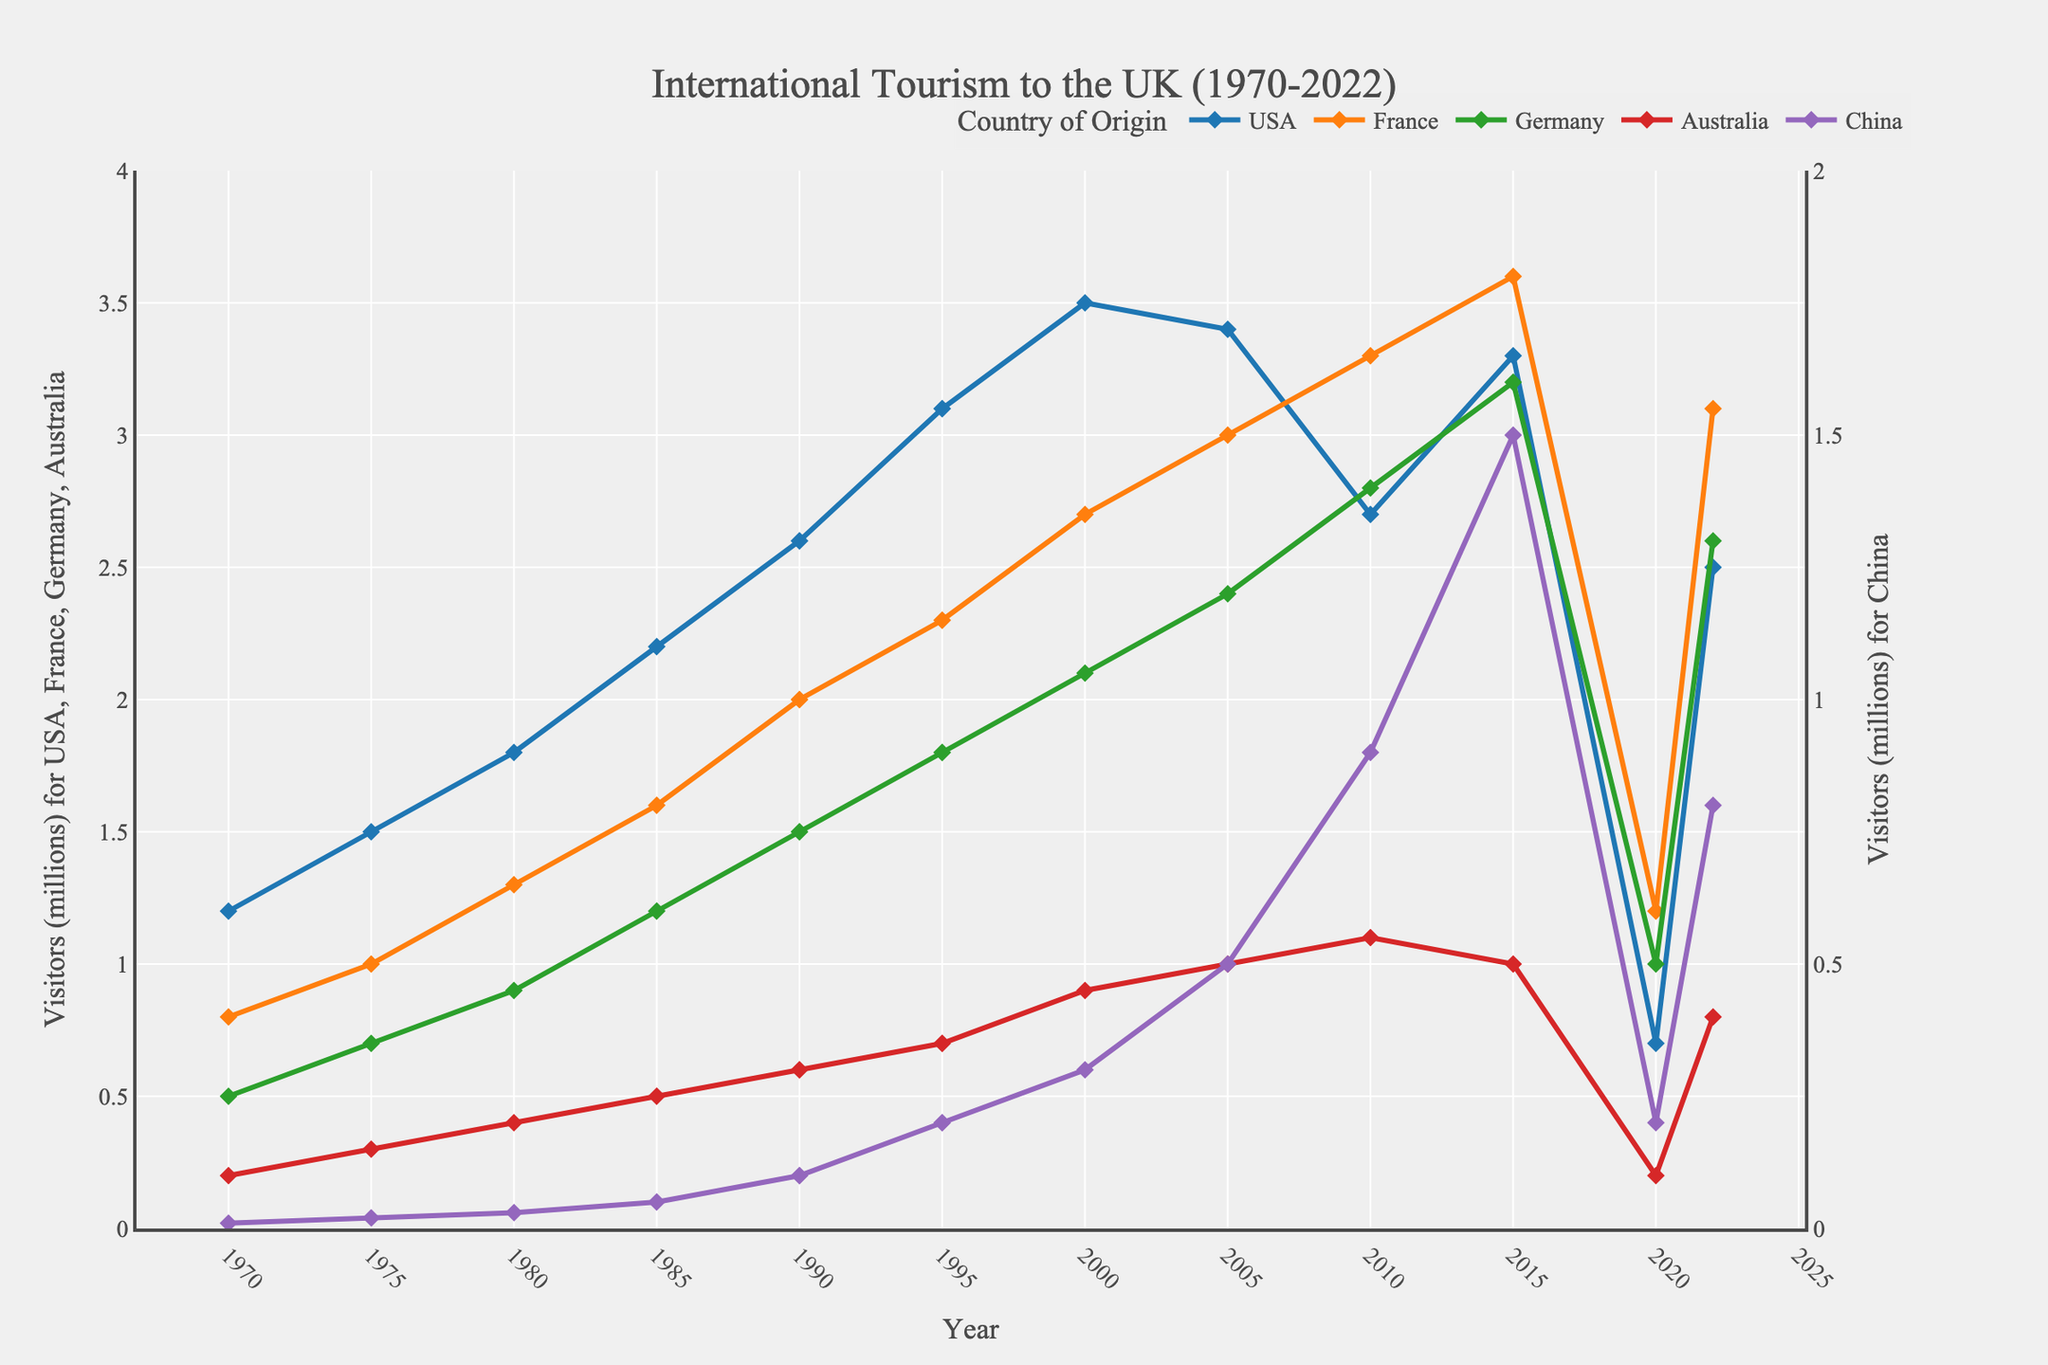Which country had the highest number of visitors to the UK in 2022? Look at the end of each line in the plot for the year 2022. The line representing France is the highest.
Answer: France How did the number of visitors from the USA change from 2019 to 2020? Compare the points for the USA in 2019 (not directly provided but can infer it's pre-COVID levels from the general year pattern) and 2020. The number dropped significantly from about 3.3 million in 2015 to 0.7 million in 2020.
Answer: Decreased significantly Which year saw the highest number of visitors from China? Follow the line designated for China and identify the peak point. This occurs in 2015 with 1.5 million visitors.
Answer: 2015 What was the total number of visitors from France, Germany, and Australia in 2005? Sum the values for these countries in 2005: France (3.0), Germany (2.4), Australia (1.0). Calculating gives 3.0 + 2.4 + 1.0 = 6.4 million.
Answer: 6.4 million Between 1970 and 2022, which country had the greatest increase in visitors to the UK? Compare the starting and ending points for each country. The visitors from the USA increased from 1.2 million to 2.5 million, France from 0.8 million to 3.1 million, Germany from 0.5 million to 2.6 million, China from 0.01 million to 0.8 million, and Australia from 0.2 million to 0.8 million. France shows the greatest increase (3.1 - 0.8 = 2.3 million).
Answer: France In which years did the USA have more visitors to the UK than Germany? Compare the lines for the USA and Germany across the timeline. The USA line stays above Germany until 2010, then is higher again in 2015, and drops below after 2020.
Answer: Before 2010, 2015 What were the visitor trends from the USA and China from 2000 to 2010? Track the lines for the USA and China between 2000 and 2010. The USA visitors decreased from 3.5 million to 2.7 million, while visitors from China increased from 0.3 million to 0.9 million.
Answer: USA decreased, China increased Was there any period when the number of visitors from Australia was constant? Check the line for Australia across the years. From 2005 to 2015, the number of visitors from Australia stayed constant at 1.0 million.
Answer: Yes, 2005 to 2015 Which country saw the steepest decline in visitors between 2019 and 2020? Compare the slopes of the lines between these years. The USA's line shows the steepest decline, dropping from around 3.3 million in 2019 to 0.7 million in 2020.
Answer: USA 